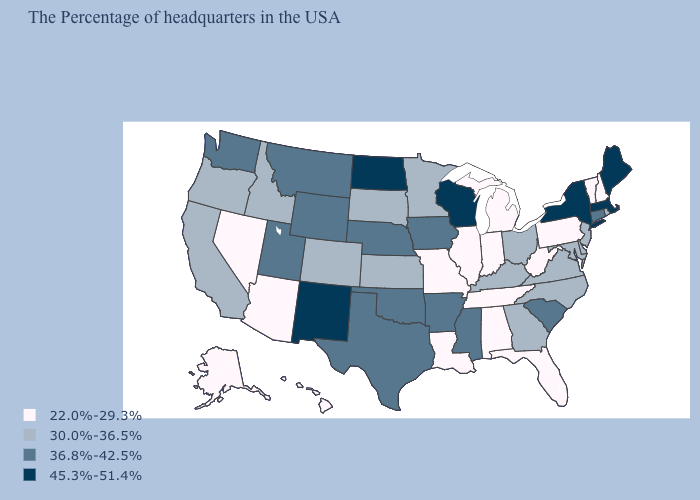Name the states that have a value in the range 22.0%-29.3%?
Keep it brief. New Hampshire, Vermont, Pennsylvania, West Virginia, Florida, Michigan, Indiana, Alabama, Tennessee, Illinois, Louisiana, Missouri, Arizona, Nevada, Alaska, Hawaii. Among the states that border Indiana , does Michigan have the lowest value?
Concise answer only. Yes. Name the states that have a value in the range 22.0%-29.3%?
Answer briefly. New Hampshire, Vermont, Pennsylvania, West Virginia, Florida, Michigan, Indiana, Alabama, Tennessee, Illinois, Louisiana, Missouri, Arizona, Nevada, Alaska, Hawaii. What is the value of North Carolina?
Quick response, please. 30.0%-36.5%. What is the value of Montana?
Keep it brief. 36.8%-42.5%. Which states have the lowest value in the USA?
Be succinct. New Hampshire, Vermont, Pennsylvania, West Virginia, Florida, Michigan, Indiana, Alabama, Tennessee, Illinois, Louisiana, Missouri, Arizona, Nevada, Alaska, Hawaii. Name the states that have a value in the range 30.0%-36.5%?
Be succinct. Rhode Island, New Jersey, Delaware, Maryland, Virginia, North Carolina, Ohio, Georgia, Kentucky, Minnesota, Kansas, South Dakota, Colorado, Idaho, California, Oregon. Name the states that have a value in the range 36.8%-42.5%?
Keep it brief. Connecticut, South Carolina, Mississippi, Arkansas, Iowa, Nebraska, Oklahoma, Texas, Wyoming, Utah, Montana, Washington. Does Pennsylvania have a lower value than California?
Be succinct. Yes. What is the highest value in the MidWest ?
Short answer required. 45.3%-51.4%. Which states have the lowest value in the West?
Give a very brief answer. Arizona, Nevada, Alaska, Hawaii. Does Virginia have the lowest value in the USA?
Quick response, please. No. What is the lowest value in the USA?
Answer briefly. 22.0%-29.3%. What is the value of Hawaii?
Short answer required. 22.0%-29.3%. Does Hawaii have the lowest value in the West?
Be succinct. Yes. 